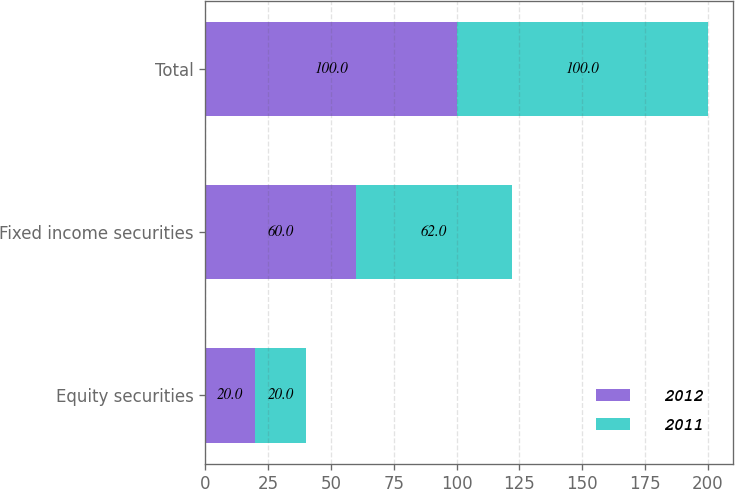<chart> <loc_0><loc_0><loc_500><loc_500><stacked_bar_chart><ecel><fcel>Equity securities<fcel>Fixed income securities<fcel>Total<nl><fcel>2012<fcel>20<fcel>60<fcel>100<nl><fcel>2011<fcel>20<fcel>62<fcel>100<nl></chart> 